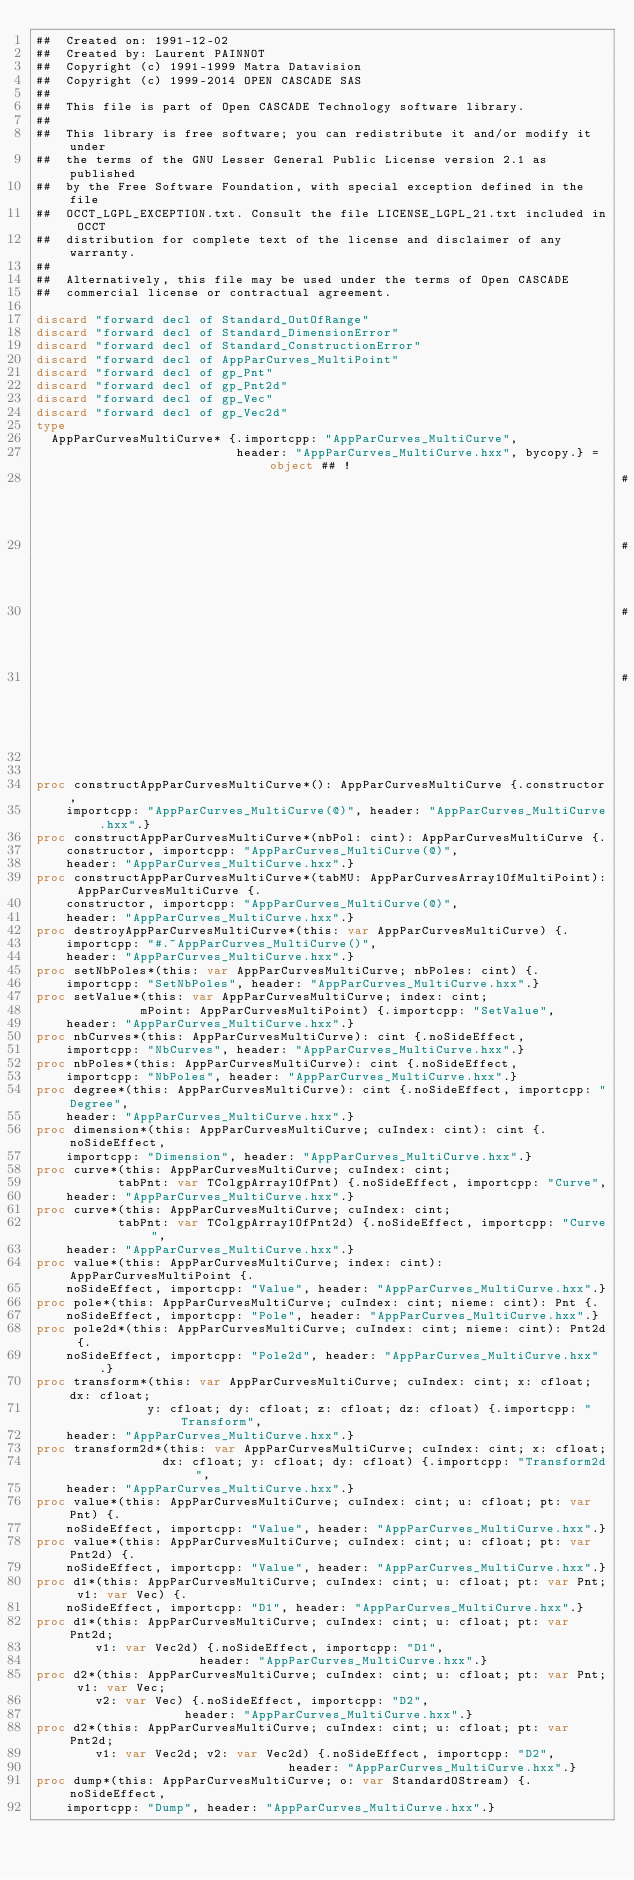<code> <loc_0><loc_0><loc_500><loc_500><_Nim_>##  Created on: 1991-12-02
##  Created by: Laurent PAINNOT
##  Copyright (c) 1991-1999 Matra Datavision
##  Copyright (c) 1999-2014 OPEN CASCADE SAS
##
##  This file is part of Open CASCADE Technology software library.
##
##  This library is free software; you can redistribute it and/or modify it under
##  the terms of the GNU Lesser General Public License version 2.1 as published
##  by the Free Software Foundation, with special exception defined in the file
##  OCCT_LGPL_EXCEPTION.txt. Consult the file LICENSE_LGPL_21.txt included in OCCT
##  distribution for complete text of the license and disclaimer of any warranty.
##
##  Alternatively, this file may be used under the terms of Open CASCADE
##  commercial license or contractual agreement.

discard "forward decl of Standard_OutOfRange"
discard "forward decl of Standard_DimensionError"
discard "forward decl of Standard_ConstructionError"
discard "forward decl of AppParCurves_MultiPoint"
discard "forward decl of gp_Pnt"
discard "forward decl of gp_Pnt2d"
discard "forward decl of gp_Vec"
discard "forward decl of gp_Vec2d"
type
  AppParCurvesMultiCurve* {.importcpp: "AppParCurves_MultiCurve",
                           header: "AppParCurves_MultiCurve.hxx", bycopy.} = object ## !
                                                                               ## returns
                                                                               ## an
                                                                               ## indefinite
                                                                               ## MultiCurve.


proc constructAppParCurvesMultiCurve*(): AppParCurvesMultiCurve {.constructor,
    importcpp: "AppParCurves_MultiCurve(@)", header: "AppParCurves_MultiCurve.hxx".}
proc constructAppParCurvesMultiCurve*(nbPol: cint): AppParCurvesMultiCurve {.
    constructor, importcpp: "AppParCurves_MultiCurve(@)",
    header: "AppParCurves_MultiCurve.hxx".}
proc constructAppParCurvesMultiCurve*(tabMU: AppParCurvesArray1OfMultiPoint): AppParCurvesMultiCurve {.
    constructor, importcpp: "AppParCurves_MultiCurve(@)",
    header: "AppParCurves_MultiCurve.hxx".}
proc destroyAppParCurvesMultiCurve*(this: var AppParCurvesMultiCurve) {.
    importcpp: "#.~AppParCurves_MultiCurve()",
    header: "AppParCurves_MultiCurve.hxx".}
proc setNbPoles*(this: var AppParCurvesMultiCurve; nbPoles: cint) {.
    importcpp: "SetNbPoles", header: "AppParCurves_MultiCurve.hxx".}
proc setValue*(this: var AppParCurvesMultiCurve; index: cint;
              mPoint: AppParCurvesMultiPoint) {.importcpp: "SetValue",
    header: "AppParCurves_MultiCurve.hxx".}
proc nbCurves*(this: AppParCurvesMultiCurve): cint {.noSideEffect,
    importcpp: "NbCurves", header: "AppParCurves_MultiCurve.hxx".}
proc nbPoles*(this: AppParCurvesMultiCurve): cint {.noSideEffect,
    importcpp: "NbPoles", header: "AppParCurves_MultiCurve.hxx".}
proc degree*(this: AppParCurvesMultiCurve): cint {.noSideEffect, importcpp: "Degree",
    header: "AppParCurves_MultiCurve.hxx".}
proc dimension*(this: AppParCurvesMultiCurve; cuIndex: cint): cint {.noSideEffect,
    importcpp: "Dimension", header: "AppParCurves_MultiCurve.hxx".}
proc curve*(this: AppParCurvesMultiCurve; cuIndex: cint;
           tabPnt: var TColgpArray1OfPnt) {.noSideEffect, importcpp: "Curve",
    header: "AppParCurves_MultiCurve.hxx".}
proc curve*(this: AppParCurvesMultiCurve; cuIndex: cint;
           tabPnt: var TColgpArray1OfPnt2d) {.noSideEffect, importcpp: "Curve",
    header: "AppParCurves_MultiCurve.hxx".}
proc value*(this: AppParCurvesMultiCurve; index: cint): AppParCurvesMultiPoint {.
    noSideEffect, importcpp: "Value", header: "AppParCurves_MultiCurve.hxx".}
proc pole*(this: AppParCurvesMultiCurve; cuIndex: cint; nieme: cint): Pnt {.
    noSideEffect, importcpp: "Pole", header: "AppParCurves_MultiCurve.hxx".}
proc pole2d*(this: AppParCurvesMultiCurve; cuIndex: cint; nieme: cint): Pnt2d {.
    noSideEffect, importcpp: "Pole2d", header: "AppParCurves_MultiCurve.hxx".}
proc transform*(this: var AppParCurvesMultiCurve; cuIndex: cint; x: cfloat; dx: cfloat;
               y: cfloat; dy: cfloat; z: cfloat; dz: cfloat) {.importcpp: "Transform",
    header: "AppParCurves_MultiCurve.hxx".}
proc transform2d*(this: var AppParCurvesMultiCurve; cuIndex: cint; x: cfloat;
                 dx: cfloat; y: cfloat; dy: cfloat) {.importcpp: "Transform2d",
    header: "AppParCurves_MultiCurve.hxx".}
proc value*(this: AppParCurvesMultiCurve; cuIndex: cint; u: cfloat; pt: var Pnt) {.
    noSideEffect, importcpp: "Value", header: "AppParCurves_MultiCurve.hxx".}
proc value*(this: AppParCurvesMultiCurve; cuIndex: cint; u: cfloat; pt: var Pnt2d) {.
    noSideEffect, importcpp: "Value", header: "AppParCurves_MultiCurve.hxx".}
proc d1*(this: AppParCurvesMultiCurve; cuIndex: cint; u: cfloat; pt: var Pnt; v1: var Vec) {.
    noSideEffect, importcpp: "D1", header: "AppParCurves_MultiCurve.hxx".}
proc d1*(this: AppParCurvesMultiCurve; cuIndex: cint; u: cfloat; pt: var Pnt2d;
        v1: var Vec2d) {.noSideEffect, importcpp: "D1",
                      header: "AppParCurves_MultiCurve.hxx".}
proc d2*(this: AppParCurvesMultiCurve; cuIndex: cint; u: cfloat; pt: var Pnt; v1: var Vec;
        v2: var Vec) {.noSideEffect, importcpp: "D2",
                    header: "AppParCurves_MultiCurve.hxx".}
proc d2*(this: AppParCurvesMultiCurve; cuIndex: cint; u: cfloat; pt: var Pnt2d;
        v1: var Vec2d; v2: var Vec2d) {.noSideEffect, importcpp: "D2",
                                  header: "AppParCurves_MultiCurve.hxx".}
proc dump*(this: AppParCurvesMultiCurve; o: var StandardOStream) {.noSideEffect,
    importcpp: "Dump", header: "AppParCurves_MultiCurve.hxx".}

























</code> 